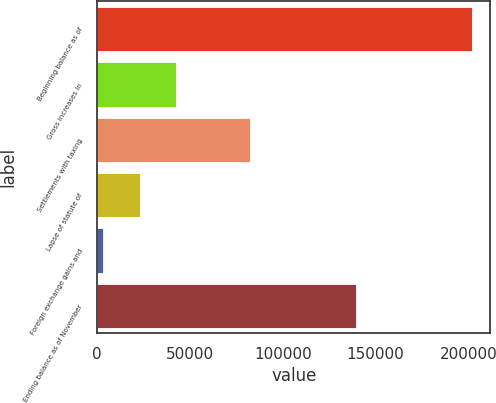Convert chart. <chart><loc_0><loc_0><loc_500><loc_500><bar_chart><fcel>Beginning balance as of<fcel>Gross increases in<fcel>Settlements with taxing<fcel>Lapse of statute of<fcel>Foreign exchange gains and<fcel>Ending balance as of November<nl><fcel>201808<fcel>42676<fcel>82459<fcel>22784.5<fcel>2893<fcel>139549<nl></chart> 